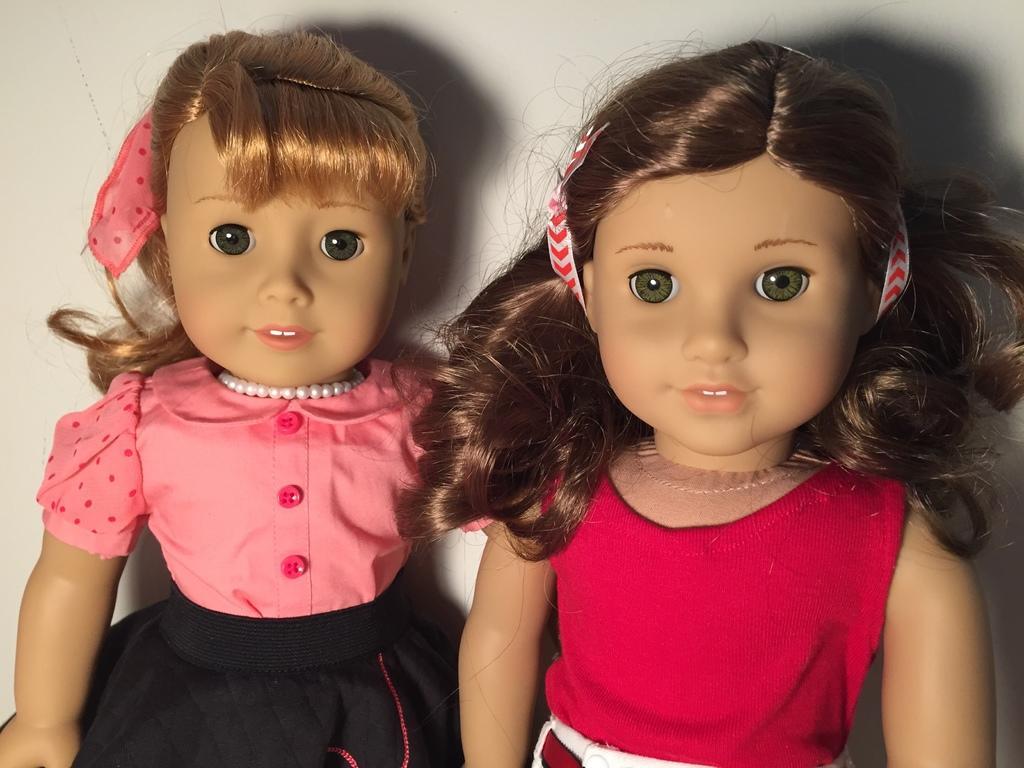In one or two sentences, can you explain what this image depicts? In this picture there is a toy with pink and black dress and there is a toy with pink and white dress. At the back there is a wall and there are shadows of the toys on the wall. 